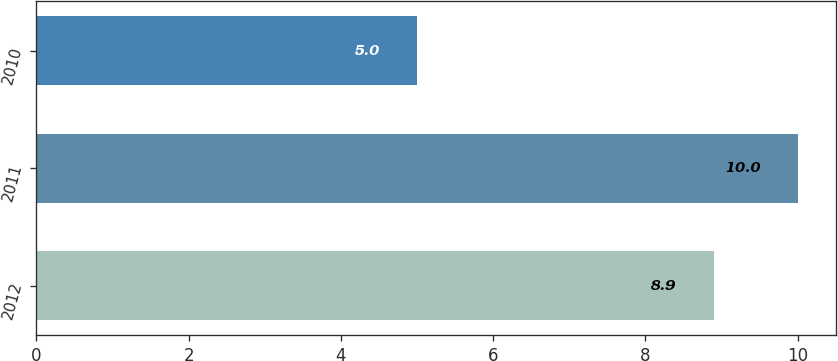Convert chart to OTSL. <chart><loc_0><loc_0><loc_500><loc_500><bar_chart><fcel>2012<fcel>2011<fcel>2010<nl><fcel>8.9<fcel>10<fcel>5<nl></chart> 